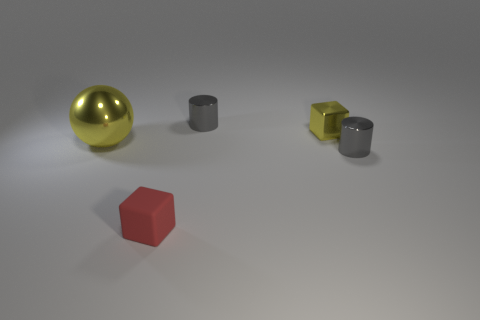Add 3 large metal things. How many objects exist? 8 Subtract all blocks. How many objects are left? 3 Add 2 red cubes. How many red cubes exist? 3 Subtract 1 yellow spheres. How many objects are left? 4 Subtract all gray shiny things. Subtract all tiny gray cylinders. How many objects are left? 1 Add 3 tiny yellow shiny blocks. How many tiny yellow shiny blocks are left? 4 